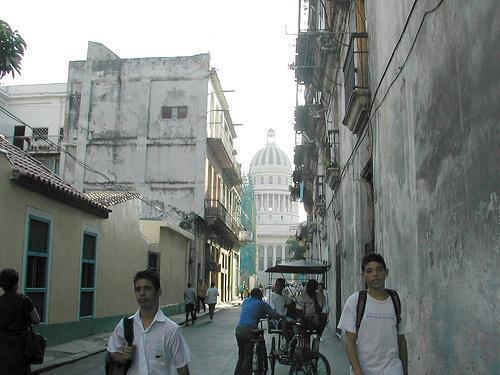How many people are there?
Give a very brief answer. 9. How many people are in the carriage?
Give a very brief answer. 2. How many people can you see?
Give a very brief answer. 4. 